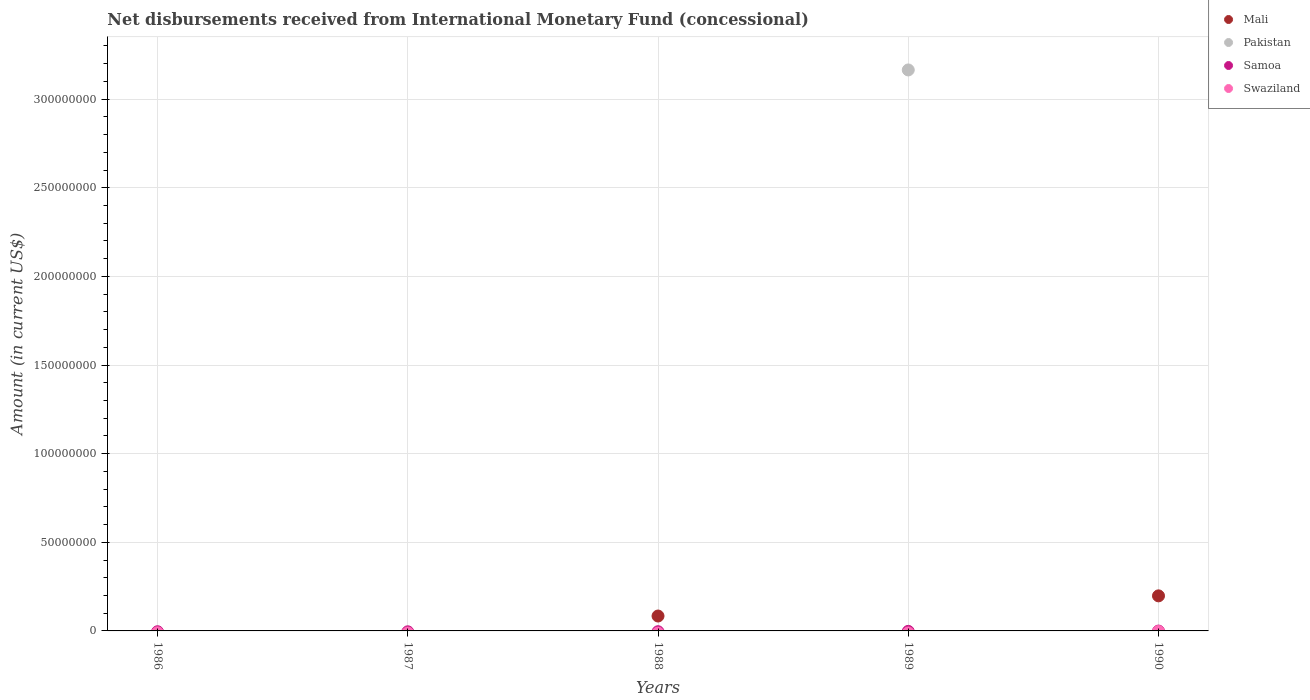How many different coloured dotlines are there?
Offer a very short reply. 2. Is the number of dotlines equal to the number of legend labels?
Make the answer very short. No. Across all years, what is the maximum amount of disbursements received from International Monetary Fund in Mali?
Make the answer very short. 1.98e+07. Across all years, what is the minimum amount of disbursements received from International Monetary Fund in Mali?
Your answer should be very brief. 0. In which year was the amount of disbursements received from International Monetary Fund in Pakistan maximum?
Your answer should be compact. 1989. What is the total amount of disbursements received from International Monetary Fund in Samoa in the graph?
Keep it short and to the point. 0. What is the difference between the amount of disbursements received from International Monetary Fund in Pakistan in 1986 and the amount of disbursements received from International Monetary Fund in Samoa in 1987?
Keep it short and to the point. 0. Is the amount of disbursements received from International Monetary Fund in Mali in 1988 less than that in 1990?
Keep it short and to the point. Yes. What is the difference between the highest and the lowest amount of disbursements received from International Monetary Fund in Mali?
Your answer should be compact. 1.98e+07. In how many years, is the amount of disbursements received from International Monetary Fund in Samoa greater than the average amount of disbursements received from International Monetary Fund in Samoa taken over all years?
Keep it short and to the point. 0. Is it the case that in every year, the sum of the amount of disbursements received from International Monetary Fund in Samoa and amount of disbursements received from International Monetary Fund in Pakistan  is greater than the sum of amount of disbursements received from International Monetary Fund in Swaziland and amount of disbursements received from International Monetary Fund in Mali?
Make the answer very short. No. Is it the case that in every year, the sum of the amount of disbursements received from International Monetary Fund in Samoa and amount of disbursements received from International Monetary Fund in Swaziland  is greater than the amount of disbursements received from International Monetary Fund in Pakistan?
Give a very brief answer. No. Does the amount of disbursements received from International Monetary Fund in Mali monotonically increase over the years?
Your answer should be very brief. No. Is the amount of disbursements received from International Monetary Fund in Swaziland strictly greater than the amount of disbursements received from International Monetary Fund in Pakistan over the years?
Give a very brief answer. No. Is the amount of disbursements received from International Monetary Fund in Samoa strictly less than the amount of disbursements received from International Monetary Fund in Pakistan over the years?
Your response must be concise. No. How many years are there in the graph?
Your response must be concise. 5. What is the difference between two consecutive major ticks on the Y-axis?
Your answer should be compact. 5.00e+07. Are the values on the major ticks of Y-axis written in scientific E-notation?
Offer a terse response. No. Does the graph contain any zero values?
Offer a terse response. Yes. Does the graph contain grids?
Provide a short and direct response. Yes. Where does the legend appear in the graph?
Provide a short and direct response. Top right. How many legend labels are there?
Offer a very short reply. 4. What is the title of the graph?
Ensure brevity in your answer.  Net disbursements received from International Monetary Fund (concessional). What is the label or title of the X-axis?
Make the answer very short. Years. What is the Amount (in current US$) in Pakistan in 1986?
Make the answer very short. 0. What is the Amount (in current US$) of Mali in 1988?
Your response must be concise. 8.41e+06. What is the Amount (in current US$) of Pakistan in 1988?
Your answer should be compact. 0. What is the Amount (in current US$) of Samoa in 1988?
Provide a succinct answer. 0. What is the Amount (in current US$) of Swaziland in 1988?
Provide a short and direct response. 0. What is the Amount (in current US$) in Mali in 1989?
Your answer should be very brief. 0. What is the Amount (in current US$) of Pakistan in 1989?
Keep it short and to the point. 3.16e+08. What is the Amount (in current US$) in Swaziland in 1989?
Make the answer very short. 0. What is the Amount (in current US$) of Mali in 1990?
Your answer should be compact. 1.98e+07. What is the Amount (in current US$) in Pakistan in 1990?
Give a very brief answer. 0. What is the Amount (in current US$) of Samoa in 1990?
Give a very brief answer. 0. Across all years, what is the maximum Amount (in current US$) in Mali?
Your answer should be compact. 1.98e+07. Across all years, what is the maximum Amount (in current US$) of Pakistan?
Provide a short and direct response. 3.16e+08. Across all years, what is the minimum Amount (in current US$) of Mali?
Provide a succinct answer. 0. Across all years, what is the minimum Amount (in current US$) of Pakistan?
Keep it short and to the point. 0. What is the total Amount (in current US$) in Mali in the graph?
Your response must be concise. 2.82e+07. What is the total Amount (in current US$) of Pakistan in the graph?
Provide a succinct answer. 3.16e+08. What is the total Amount (in current US$) in Samoa in the graph?
Offer a terse response. 0. What is the difference between the Amount (in current US$) of Mali in 1988 and that in 1990?
Provide a succinct answer. -1.14e+07. What is the difference between the Amount (in current US$) of Mali in 1988 and the Amount (in current US$) of Pakistan in 1989?
Provide a succinct answer. -3.08e+08. What is the average Amount (in current US$) in Mali per year?
Ensure brevity in your answer.  5.64e+06. What is the average Amount (in current US$) of Pakistan per year?
Your answer should be compact. 6.33e+07. What is the average Amount (in current US$) of Samoa per year?
Your response must be concise. 0. What is the ratio of the Amount (in current US$) in Mali in 1988 to that in 1990?
Your response must be concise. 0.42. What is the difference between the highest and the lowest Amount (in current US$) of Mali?
Keep it short and to the point. 1.98e+07. What is the difference between the highest and the lowest Amount (in current US$) in Pakistan?
Ensure brevity in your answer.  3.16e+08. 